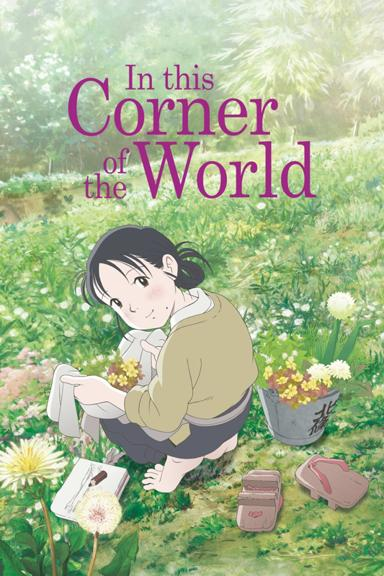Can you describe the girl's surroundings in the image? The girl is sitting in the grass surrounded by flowers. 